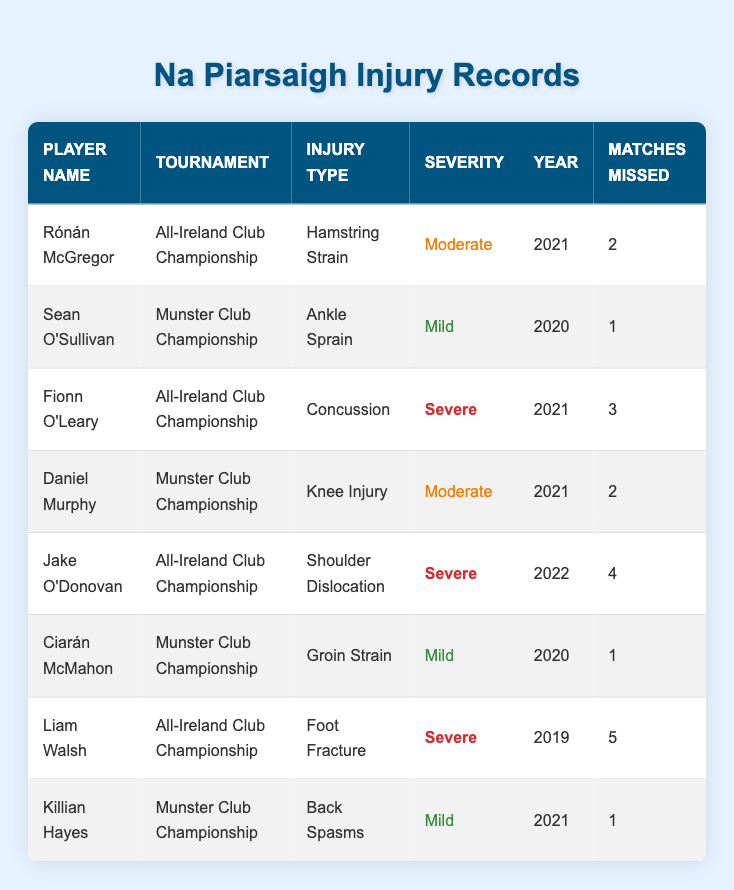What injury did Rónán McGregor sustain in the All-Ireland Club Championship? According to the table, Rónán McGregor's injury type listed under the "All-Ireland Club Championship" is "Hamstring Strain."
Answer: Hamstring Strain How many matches did Fionn O'Leary miss during the All-Ireland Club Championship in 2021? The table indicates that Fionn O'Leary missed 3 matches during the All-Ireland Club Championship in 2021.
Answer: 3 Who had the most severe injury in the All-Ireland Club Championship? From the data, both Liam Walsh (Foot Fracture) and Fionn O'Leary (Concussion) were classified as severe injuries in the All-Ireland Club Championship, but Liam Walsh's injury caused him to miss more matches (5 matches).
Answer: Liam Walsh and Fionn O'Leary How many players missed matches in the Munster Club Championship? Based on the table, three players missed matches in the Munster Club Championship: Sean O'Sullivan (1 match), Daniel Murphy (2 matches), and Killian Hayes (1 match). So, the total count of players is 3.
Answer: 3 Was there any player in the 2021 Munster Club Championship who had a mild injury? The table shows that Killian Hayes had a mild injury (Back Spasms) in the 2021 Munster Club Championship, confirming that there is at least one player with a mild injury.
Answer: Yes What is the total number of matches missed by all players during the All-Ireland Club Championship? By summing the matches missed by players in the All-Ireland Club Championship: Rónán McGregor (2) + Fionn O'Leary (3) + Liam Walsh (5) + Jake O'Donovan (4) gives 2 + 3 + 5 + 4 = 14 matches.
Answer: 14 Which tournament in 2021 had the highest missed matches combined? Analyzing the table, for the Munster Club Championship in 2021: Daniel Murphy (2) + Killian Hayes (1) sums to 3 matches missed, and for the All-Ireland Club Championship: Rónán McGregor (2) + Fionn O'Leary (3) + Jake O'Donovan (4) totals to 9 matches. Therefore, the All-Ireland Club Championship in 2021 had the higher total.
Answer: All-Ireland Club Championship How many players sustained mild injuries during the tournaments? The table lists 4 players with mild injuries: Sean O'Sullivan (1) in Munster Club Championship, Ciarán McMahon (1) in Munster Club Championship, and Killian Hayes (1) in Munster Club Championship, so the total is 3 players.
Answer: 3 What injury type was sustained by Jake O'Donovan, and how severe was it? The table records Jake O'Donovan's injury as "Shoulder Dislocation," and its severity is classified as "Severe."
Answer: Shoulder Dislocation, Severe 